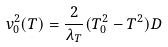<formula> <loc_0><loc_0><loc_500><loc_500>v _ { 0 } ^ { 2 } ( T ) = \frac { 2 } { \lambda _ { T } } ( T ^ { 2 } _ { 0 } - T ^ { 2 } ) D</formula> 